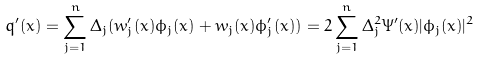Convert formula to latex. <formula><loc_0><loc_0><loc_500><loc_500>q ^ { \prime } ( x ) = \sum _ { j = 1 } ^ { n } \Delta _ { j } ( w _ { j } ^ { \prime } ( x ) \phi _ { j } ( x ) + w _ { j } ( x ) \phi _ { j } ^ { \prime } ( x ) ) = 2 \sum _ { j = 1 } ^ { n } \Delta _ { j } ^ { 2 } \Psi ^ { \prime } ( x ) | \phi _ { j } ( x ) | ^ { 2 }</formula> 